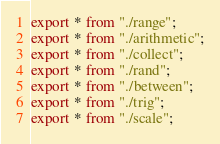Convert code to text. <code><loc_0><loc_0><loc_500><loc_500><_TypeScript_>export * from "./range";
export * from "./arithmetic";
export * from "./collect";
export * from "./rand";
export * from "./between";
export * from "./trig";
export * from "./scale";
</code> 